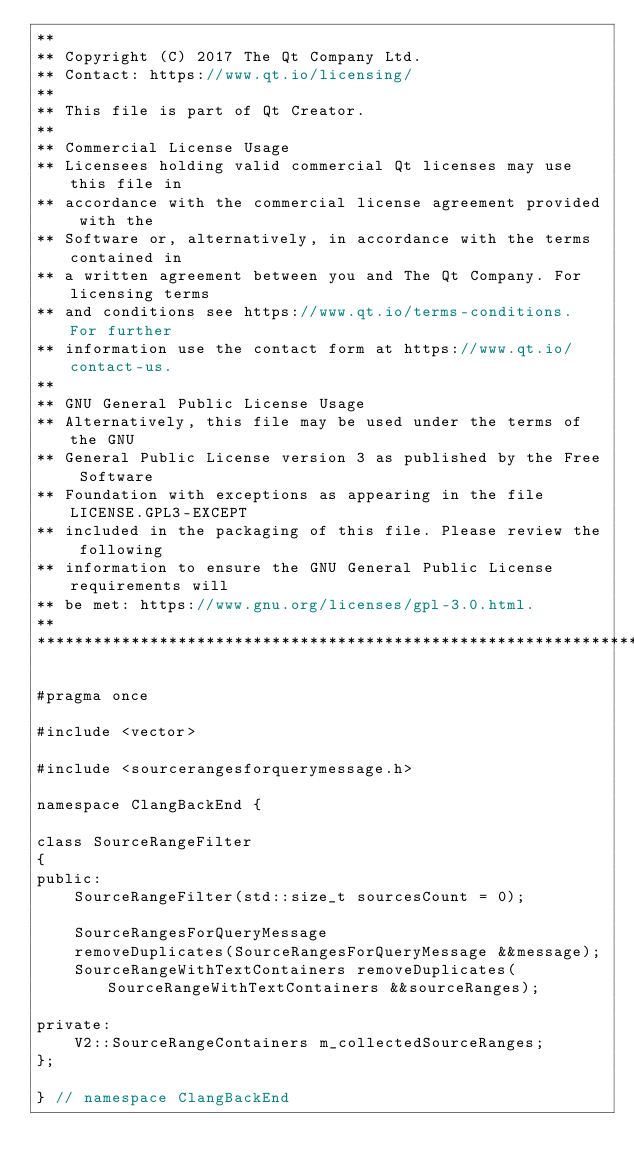<code> <loc_0><loc_0><loc_500><loc_500><_C_>**
** Copyright (C) 2017 The Qt Company Ltd.
** Contact: https://www.qt.io/licensing/
**
** This file is part of Qt Creator.
**
** Commercial License Usage
** Licensees holding valid commercial Qt licenses may use this file in
** accordance with the commercial license agreement provided with the
** Software or, alternatively, in accordance with the terms contained in
** a written agreement between you and The Qt Company. For licensing terms
** and conditions see https://www.qt.io/terms-conditions. For further
** information use the contact form at https://www.qt.io/contact-us.
**
** GNU General Public License Usage
** Alternatively, this file may be used under the terms of the GNU
** General Public License version 3 as published by the Free Software
** Foundation with exceptions as appearing in the file LICENSE.GPL3-EXCEPT
** included in the packaging of this file. Please review the following
** information to ensure the GNU General Public License requirements will
** be met: https://www.gnu.org/licenses/gpl-3.0.html.
**
****************************************************************************/

#pragma once

#include <vector>

#include <sourcerangesforquerymessage.h>

namespace ClangBackEnd {

class SourceRangeFilter
{
public:
    SourceRangeFilter(std::size_t sourcesCount = 0);

    SourceRangesForQueryMessage
    removeDuplicates(SourceRangesForQueryMessage &&message);
    SourceRangeWithTextContainers removeDuplicates(SourceRangeWithTextContainers &&sourceRanges);

private:
    V2::SourceRangeContainers m_collectedSourceRanges;
};

} // namespace ClangBackEnd
</code> 